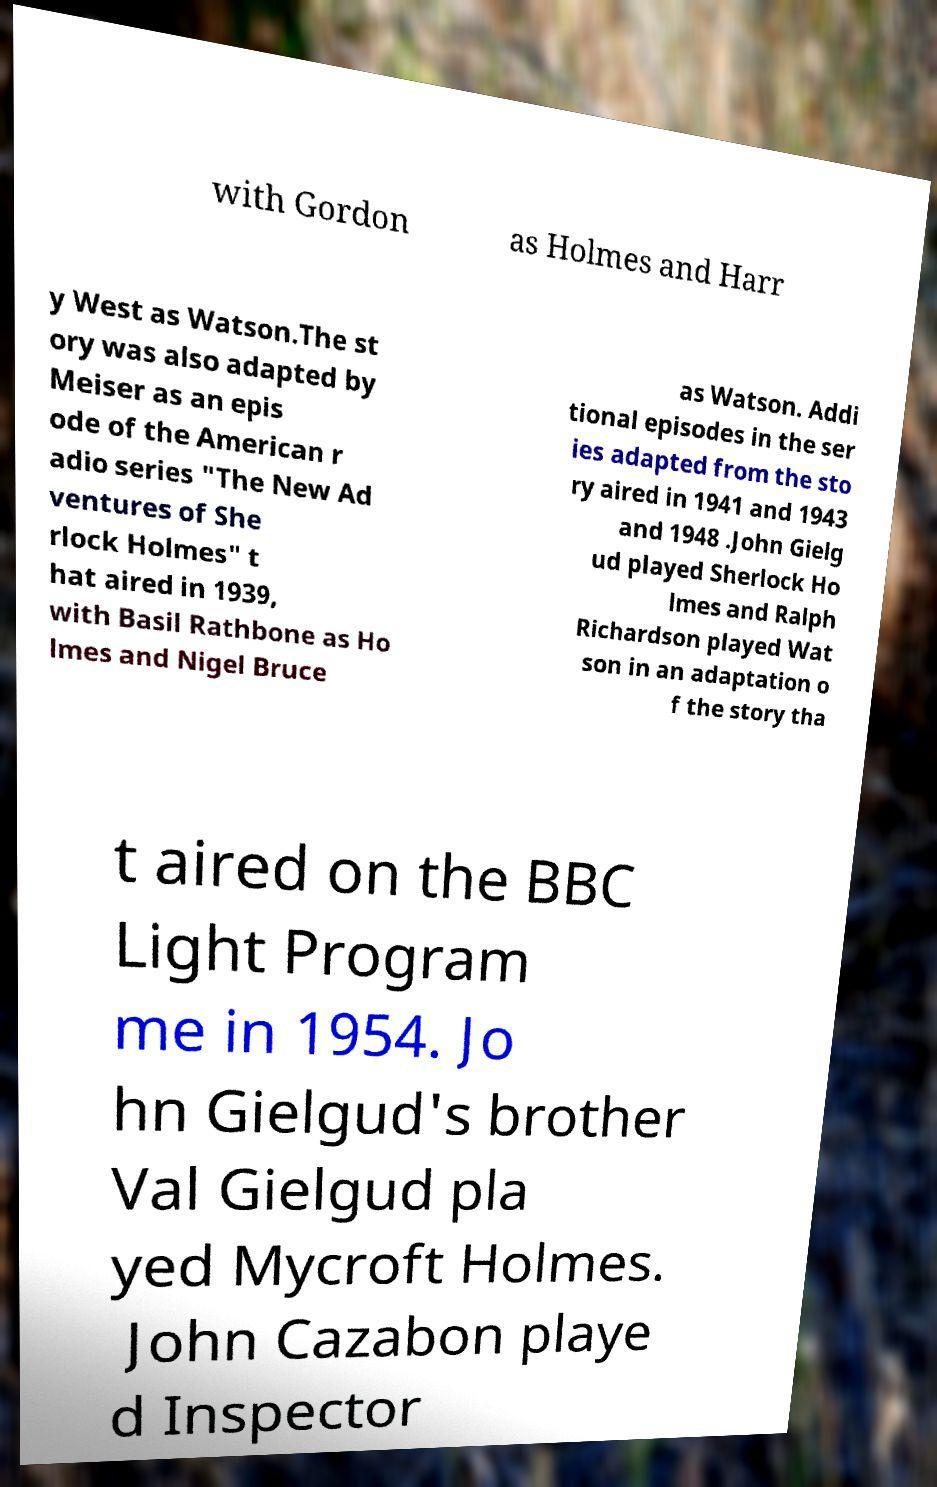Please read and relay the text visible in this image. What does it say? with Gordon as Holmes and Harr y West as Watson.The st ory was also adapted by Meiser as an epis ode of the American r adio series "The New Ad ventures of She rlock Holmes" t hat aired in 1939, with Basil Rathbone as Ho lmes and Nigel Bruce as Watson. Addi tional episodes in the ser ies adapted from the sto ry aired in 1941 and 1943 and 1948 .John Gielg ud played Sherlock Ho lmes and Ralph Richardson played Wat son in an adaptation o f the story tha t aired on the BBC Light Program me in 1954. Jo hn Gielgud's brother Val Gielgud pla yed Mycroft Holmes. John Cazabon playe d Inspector 